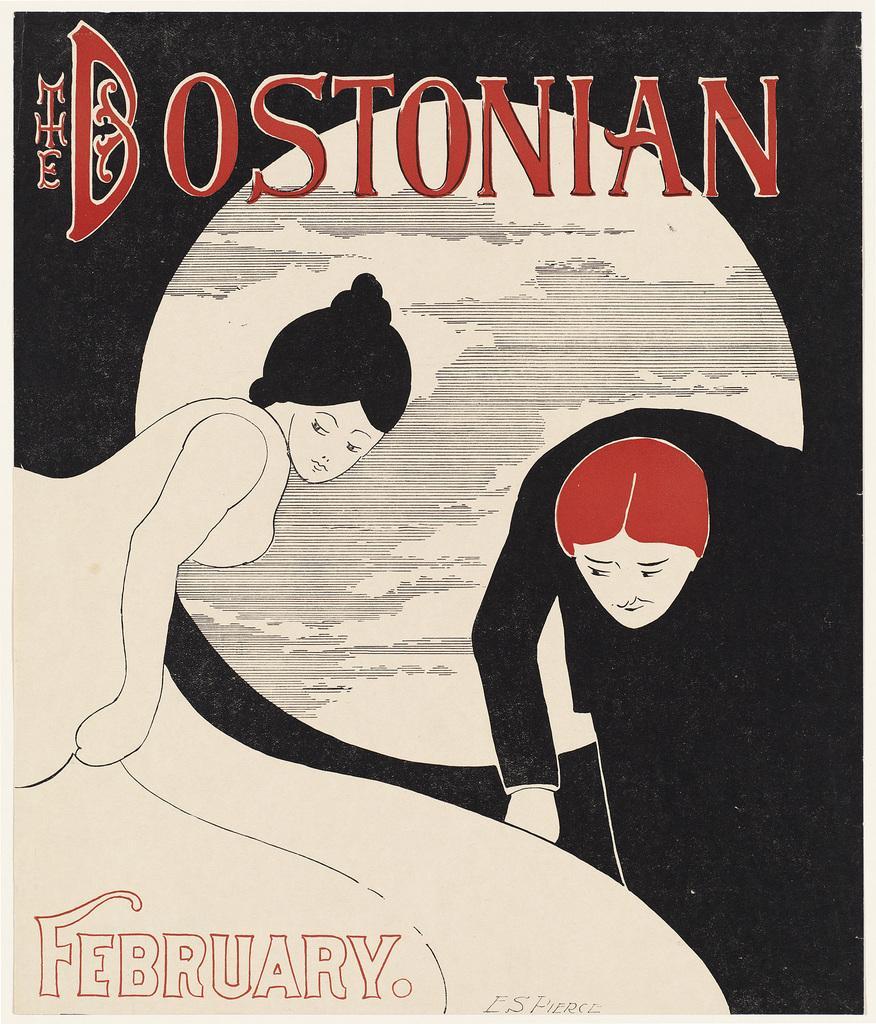Can you describe this image briefly? There is a poster having paintings of persons and the moon and there are texts on this poster. And the background of this poster is black and white color combination. 